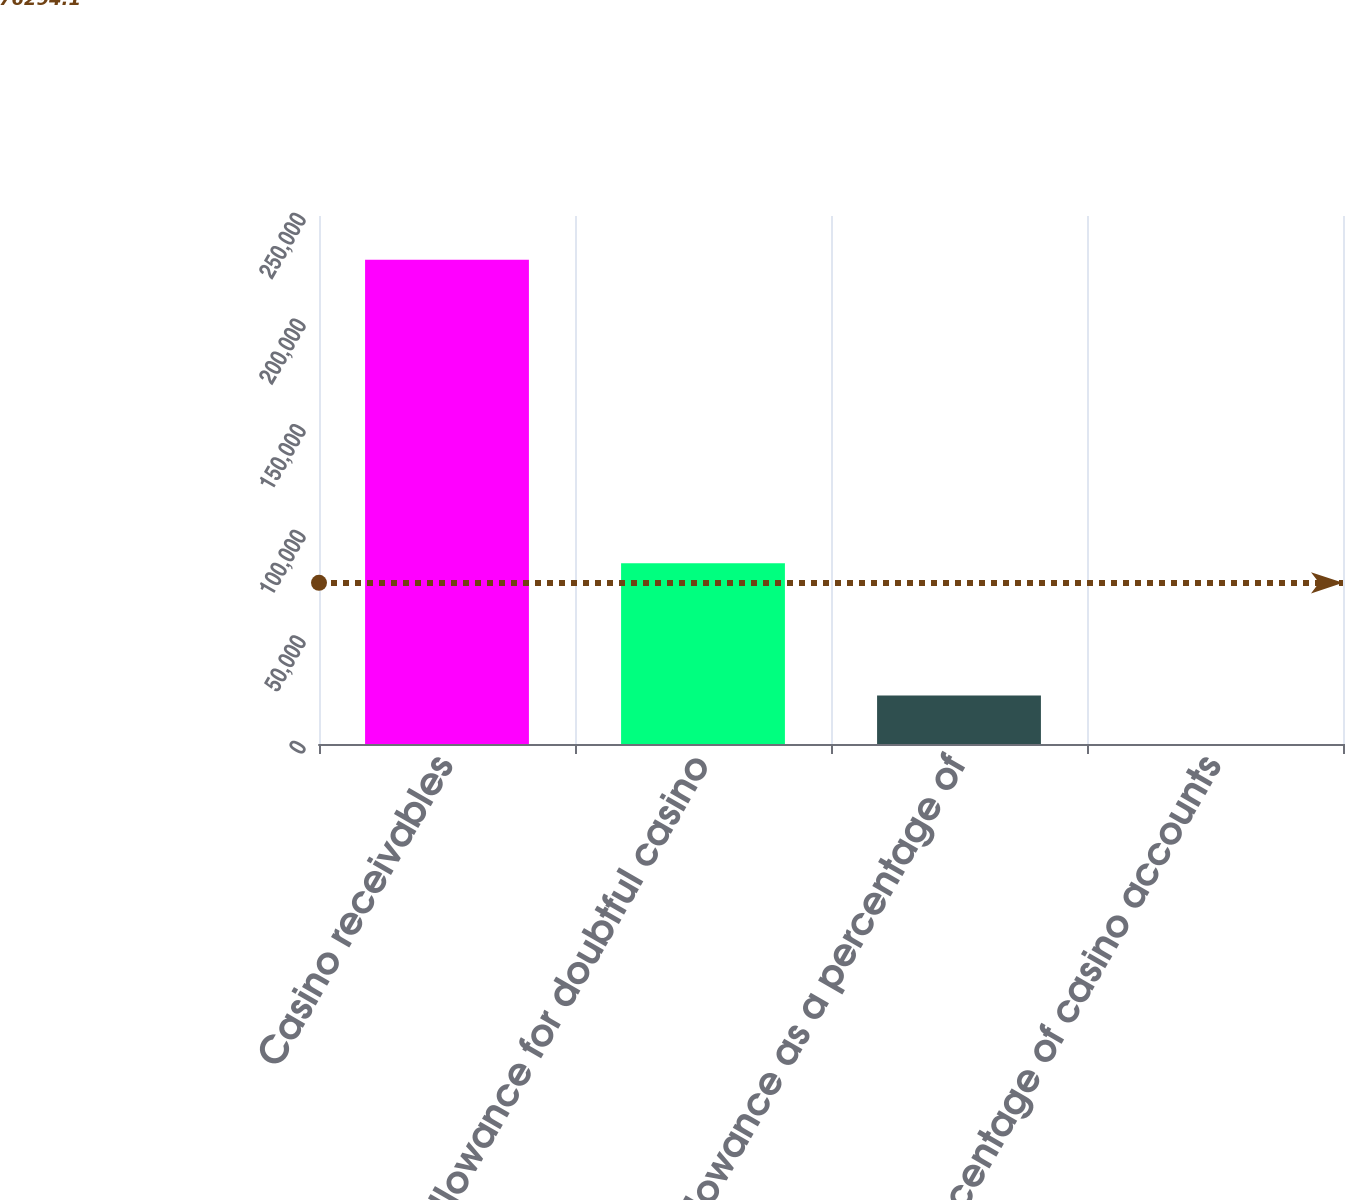Convert chart to OTSL. <chart><loc_0><loc_0><loc_500><loc_500><bar_chart><fcel>Casino receivables<fcel>Allowance for doubtful casino<fcel>Allowance as a percentage of<fcel>Percentage of casino accounts<nl><fcel>229318<fcel>85547<fcel>22957<fcel>28<nl></chart> 